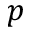Convert formula to latex. <formula><loc_0><loc_0><loc_500><loc_500>p</formula> 